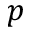Convert formula to latex. <formula><loc_0><loc_0><loc_500><loc_500>p</formula> 